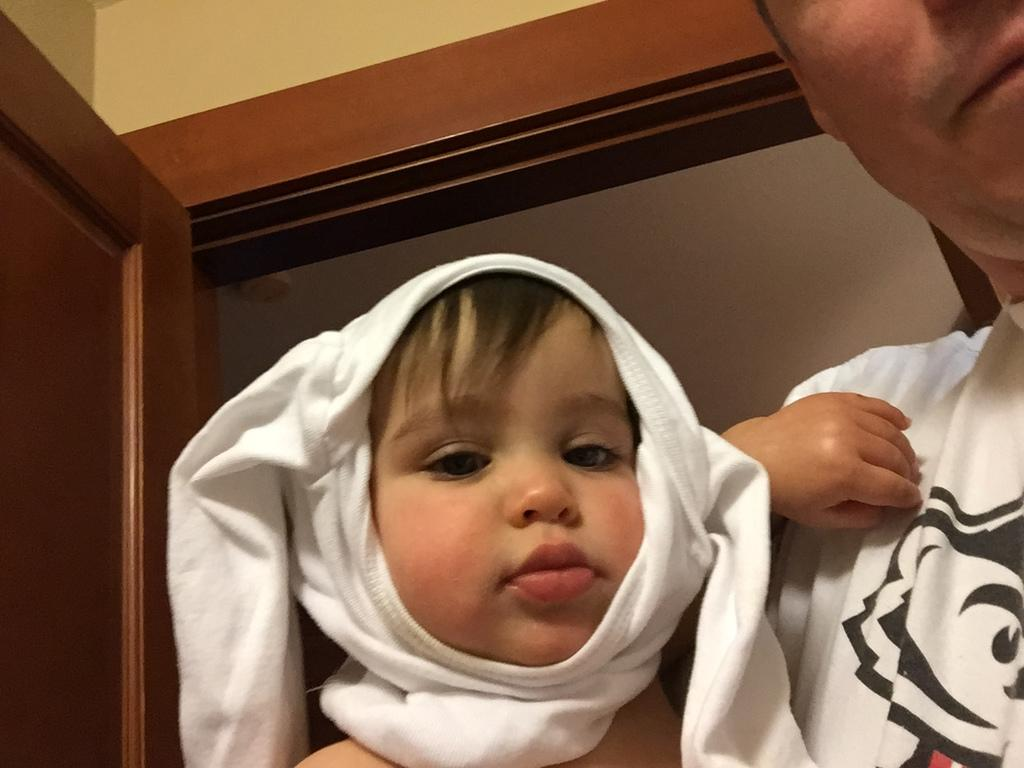Who or what can be seen in the image? There are people in the image. What is located on the left side of the image? There is a door on the left side of the image. Can you describe the object in the image? Unfortunately, the provided facts do not give enough information to describe the object in the image. What type of card is being used to cover the stone in the image? There is no card or stone present in the image. 